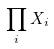<formula> <loc_0><loc_0><loc_500><loc_500>\prod _ { i } X _ { i }</formula> 